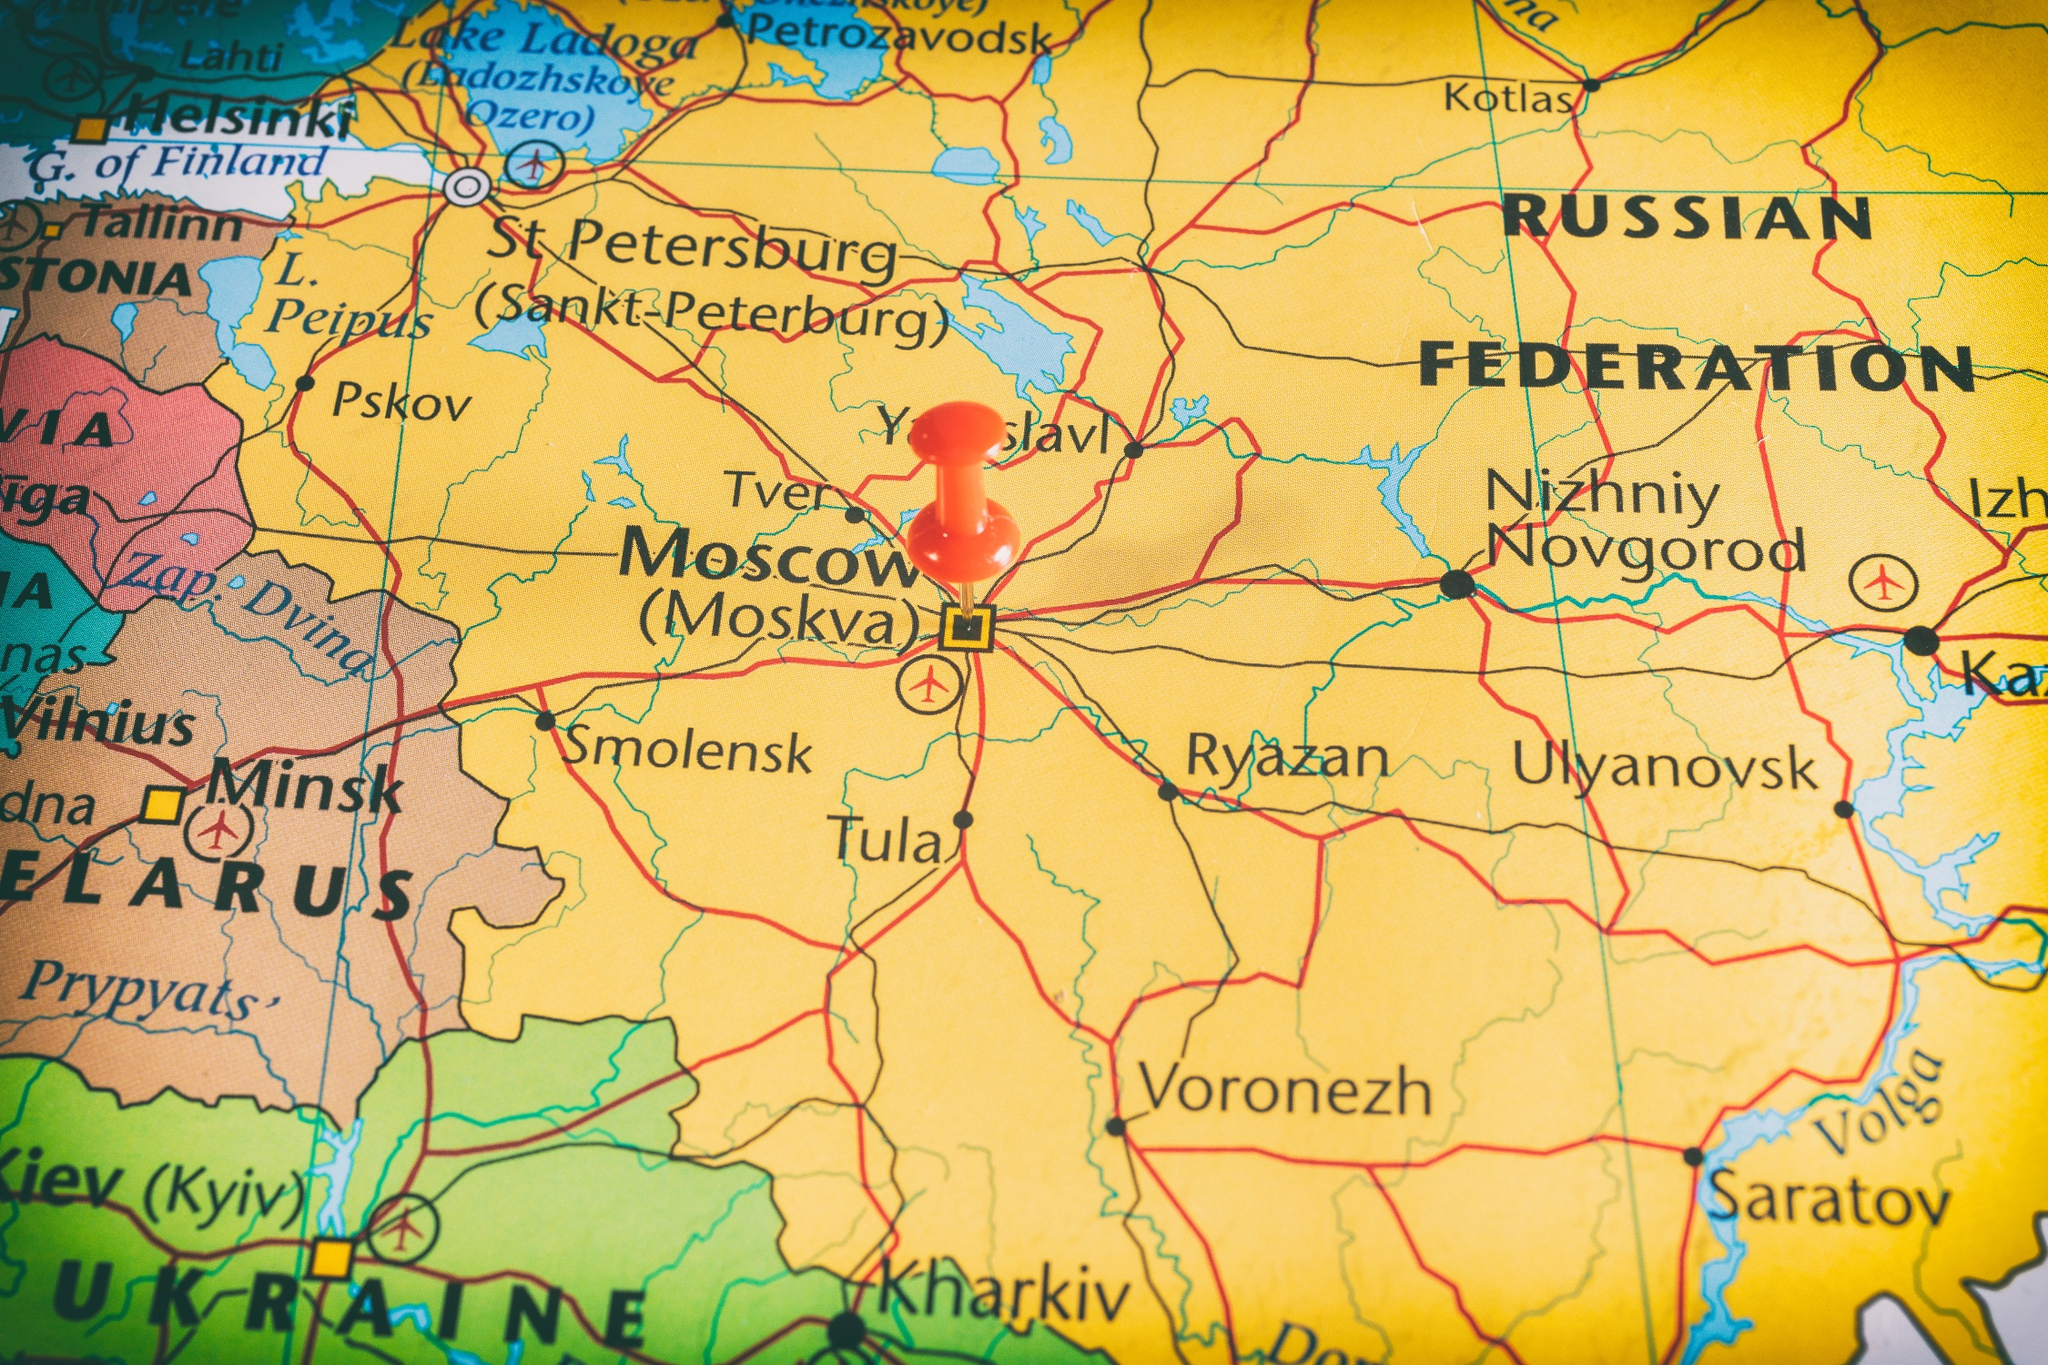Analyze the image in a comprehensive and detailed manner. This image features a detailed and vibrant map of a section of Russia and its neighboring countries. Russia is prominently highlighted in bright yellow, making the country's extensive boundaries easily visible. The surrounding nations such as Belarus, Ukraine, and Finland are depicted in contrasting shades of pink and green. This distinction helps in quickly identifying the geopolitical boundaries. Major cities like Moscow, St. Petersburg, and Nizhniy Novgorod are clearly labeled, along with significant road networks, indicating important transportation routes. Moscow, the capital city, is particularly emphasized with a red pin and bold labeling, drawing immediate attention to its location. The perspective of the image is as if viewed from above, giving it a bird's-eye view. The detail in the map offers insights into the geographical layout of Russia and the placement of key cities and roads. There is no imaginary content, ensuring that the map provides a factual representation of the region's geography. However, the identifier 'sa_15978' included in the description does not offer any further landmark information. 